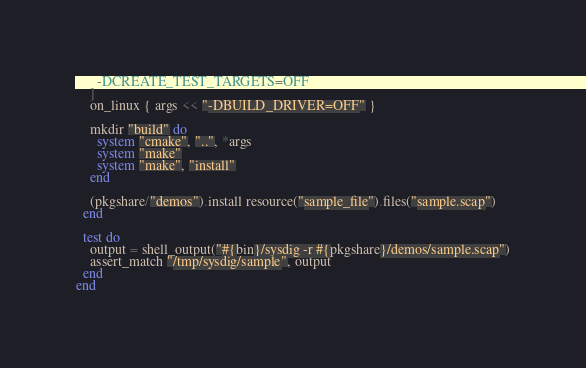<code> <loc_0><loc_0><loc_500><loc_500><_Ruby_>      -DCREATE_TEST_TARGETS=OFF
    ]
    on_linux { args << "-DBUILD_DRIVER=OFF" }

    mkdir "build" do
      system "cmake", "..", *args
      system "make"
      system "make", "install"
    end

    (pkgshare/"demos").install resource("sample_file").files("sample.scap")
  end

  test do
    output = shell_output("#{bin}/sysdig -r #{pkgshare}/demos/sample.scap")
    assert_match "/tmp/sysdig/sample", output
  end
end
</code> 